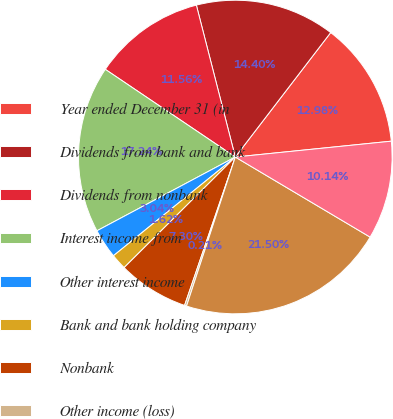Convert chart. <chart><loc_0><loc_0><loc_500><loc_500><pie_chart><fcel>Year ended December 31 (in<fcel>Dividends from bank and bank<fcel>Dividends from nonbank<fcel>Interest income from<fcel>Other interest income<fcel>Bank and bank holding company<fcel>Nonbank<fcel>Other income (loss)<fcel>Total income<fcel>Interest expense to<nl><fcel>12.98%<fcel>14.4%<fcel>11.56%<fcel>17.24%<fcel>3.04%<fcel>1.62%<fcel>7.3%<fcel>0.21%<fcel>21.5%<fcel>10.14%<nl></chart> 